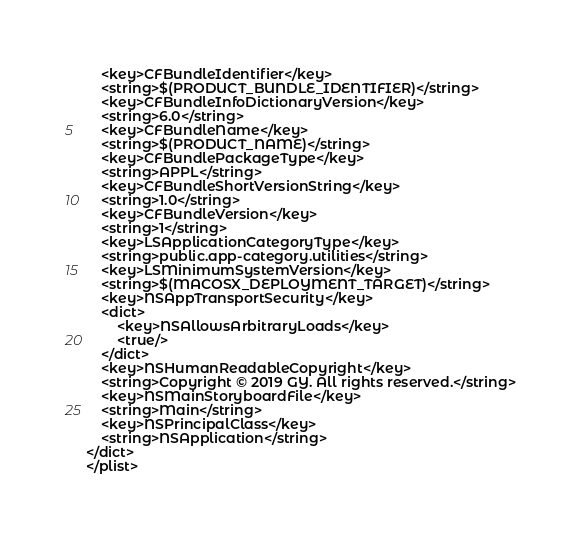Convert code to text. <code><loc_0><loc_0><loc_500><loc_500><_XML_>	<key>CFBundleIdentifier</key>
	<string>$(PRODUCT_BUNDLE_IDENTIFIER)</string>
	<key>CFBundleInfoDictionaryVersion</key>
	<string>6.0</string>
	<key>CFBundleName</key>
	<string>$(PRODUCT_NAME)</string>
	<key>CFBundlePackageType</key>
	<string>APPL</string>
	<key>CFBundleShortVersionString</key>
	<string>1.0</string>
	<key>CFBundleVersion</key>
	<string>1</string>
	<key>LSApplicationCategoryType</key>
	<string>public.app-category.utilities</string>
	<key>LSMinimumSystemVersion</key>
	<string>$(MACOSX_DEPLOYMENT_TARGET)</string>
	<key>NSAppTransportSecurity</key>
	<dict>
		<key>NSAllowsArbitraryLoads</key>
		<true/>
	</dict>
	<key>NSHumanReadableCopyright</key>
	<string>Copyright © 2019 GY. All rights reserved.</string>
	<key>NSMainStoryboardFile</key>
	<string>Main</string>
	<key>NSPrincipalClass</key>
	<string>NSApplication</string>
</dict>
</plist>
</code> 